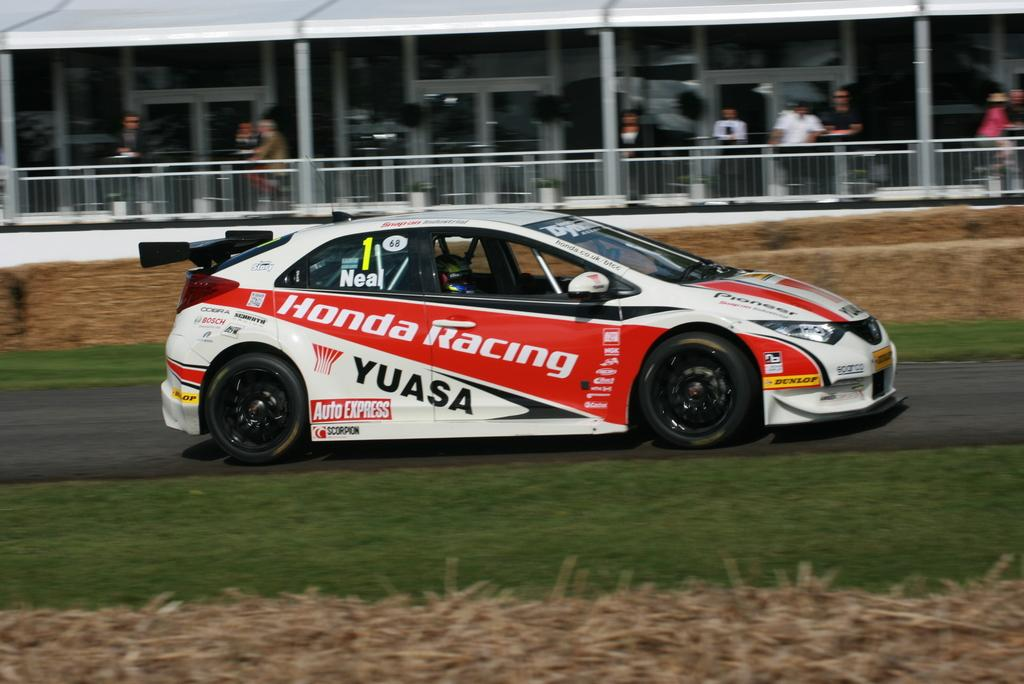What is the main subject of the image? The main subject of the image is a racing car. Where is the racing car located in the image? The racing car is parked on the road. What else can be seen in the image besides the racing car? There is a building and people standing in the building, as well as grass covering the ground. Can you see the smile on the racing car's legs in the image? There are no smiles or legs present on the racing car in the image, as it is an inanimate object. 